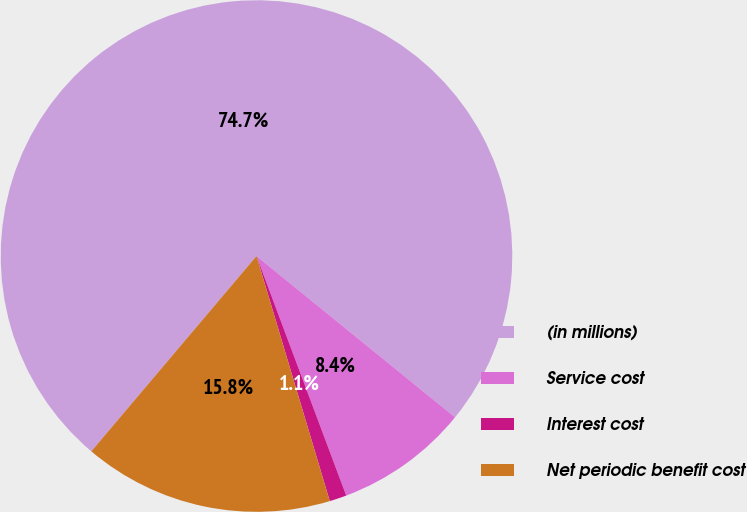Convert chart to OTSL. <chart><loc_0><loc_0><loc_500><loc_500><pie_chart><fcel>(in millions)<fcel>Service cost<fcel>Interest cost<fcel>Net periodic benefit cost<nl><fcel>74.69%<fcel>8.44%<fcel>1.08%<fcel>15.8%<nl></chart> 